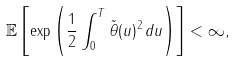Convert formula to latex. <formula><loc_0><loc_0><loc_500><loc_500>\mathbb { E } \left [ \exp \left ( \frac { 1 } { 2 } \int _ { 0 } ^ { T } \| \tilde { \theta } ( u ) \| ^ { 2 } \, d u \right ) \right ] < \infty ,</formula> 